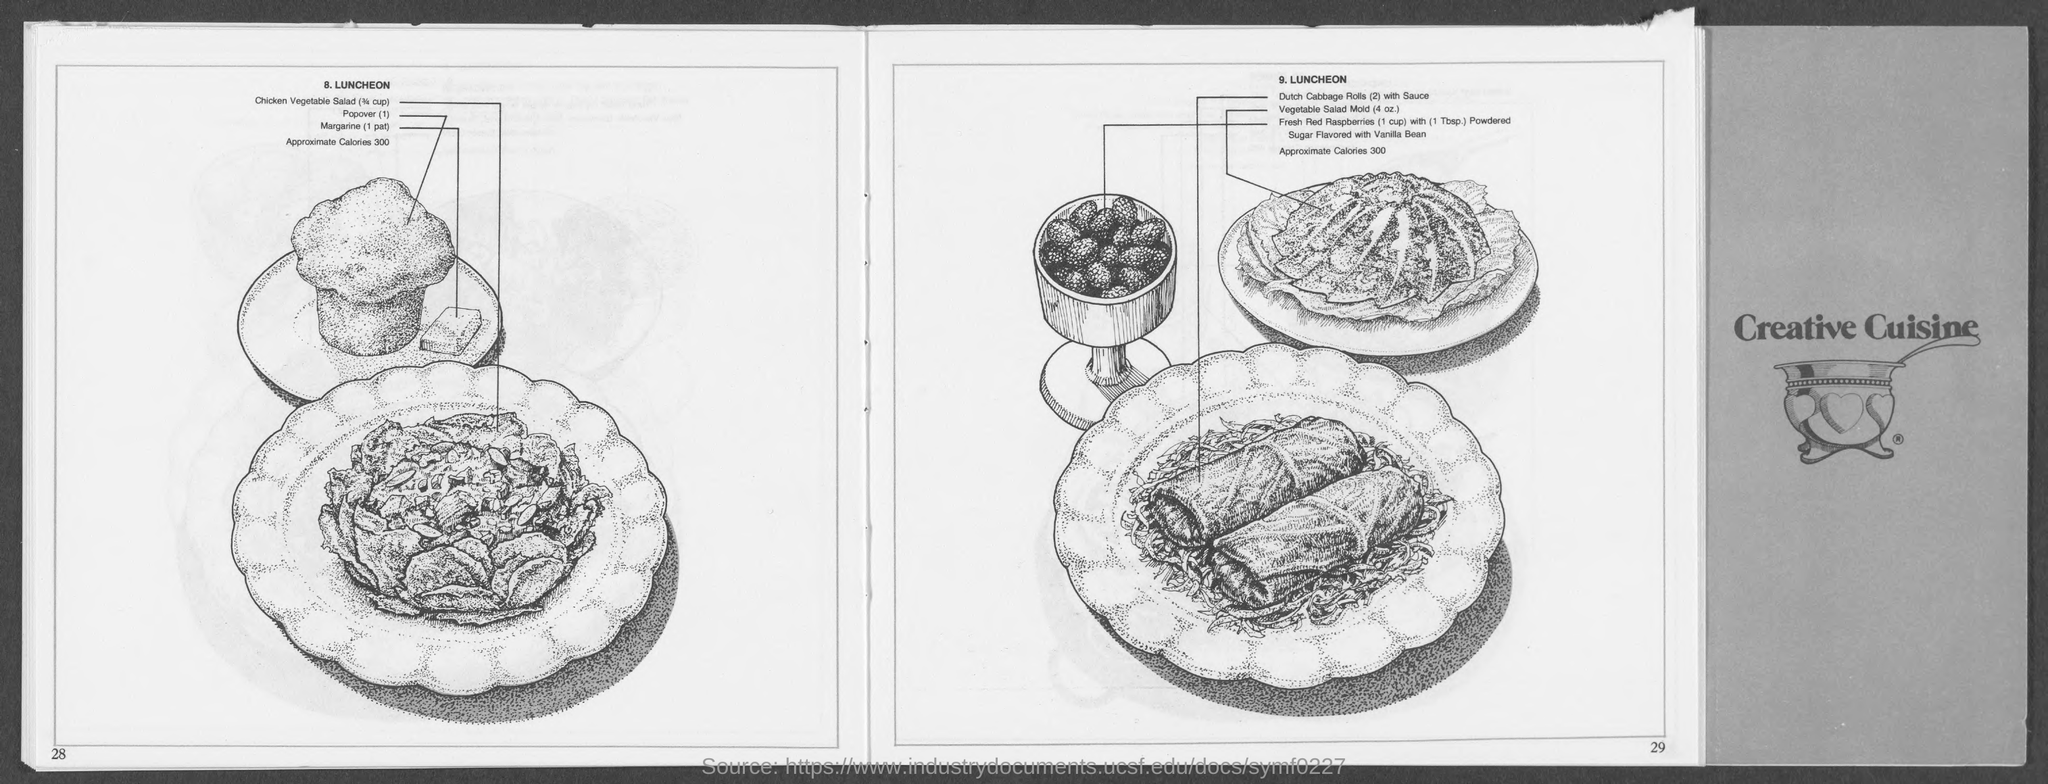What is the third dish in 8.LUNCHEON?
Make the answer very short. Margarine (1 pat). 